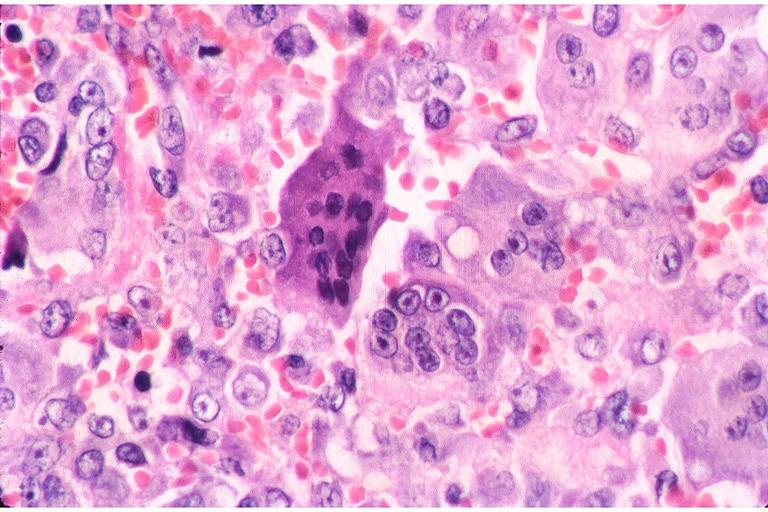what does this image show?
Answer the question using a single word or phrase. Central giant cell lesion 